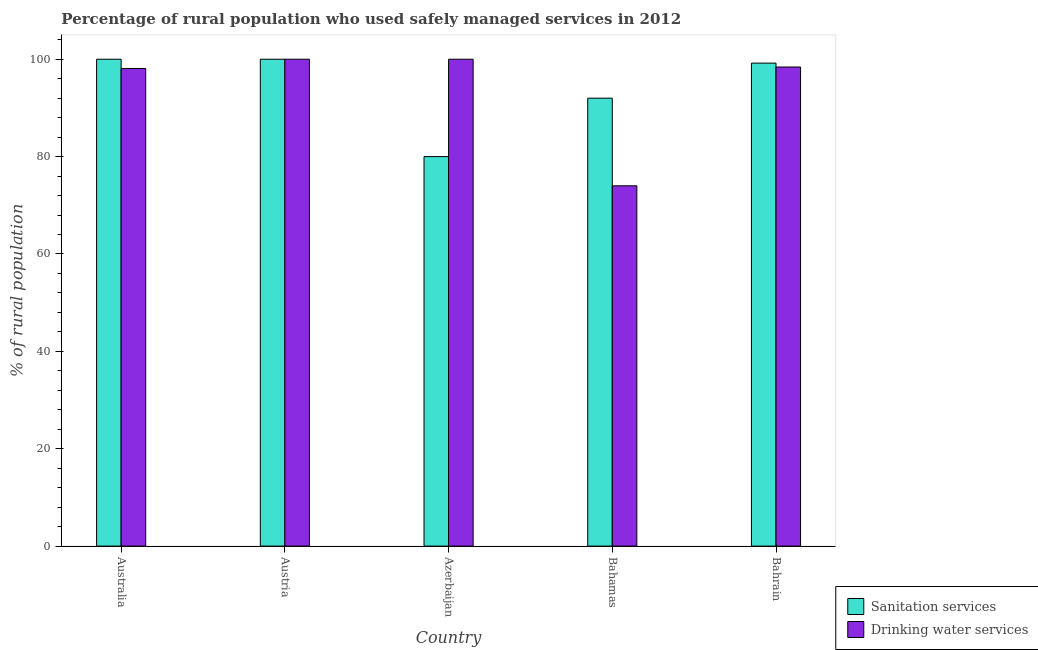How many groups of bars are there?
Make the answer very short. 5. How many bars are there on the 2nd tick from the right?
Offer a terse response. 2. What is the label of the 1st group of bars from the left?
Ensure brevity in your answer.  Australia. In how many cases, is the number of bars for a given country not equal to the number of legend labels?
Provide a succinct answer. 0. What is the percentage of rural population who used sanitation services in Austria?
Offer a terse response. 100. In which country was the percentage of rural population who used sanitation services minimum?
Make the answer very short. Azerbaijan. What is the total percentage of rural population who used sanitation services in the graph?
Your response must be concise. 471.2. What is the difference between the percentage of rural population who used drinking water services in Australia and that in Austria?
Your answer should be very brief. -1.9. What is the difference between the percentage of rural population who used drinking water services in Bahrain and the percentage of rural population who used sanitation services in Austria?
Offer a terse response. -1.6. What is the average percentage of rural population who used sanitation services per country?
Your answer should be very brief. 94.24. What is the difference between the percentage of rural population who used drinking water services and percentage of rural population who used sanitation services in Bahrain?
Give a very brief answer. -0.8. In how many countries, is the percentage of rural population who used sanitation services greater than the average percentage of rural population who used sanitation services taken over all countries?
Ensure brevity in your answer.  3. What does the 1st bar from the left in Bahamas represents?
Your answer should be compact. Sanitation services. What does the 1st bar from the right in Bahamas represents?
Ensure brevity in your answer.  Drinking water services. How many bars are there?
Offer a very short reply. 10. Are all the bars in the graph horizontal?
Your answer should be very brief. No. How many countries are there in the graph?
Give a very brief answer. 5. Are the values on the major ticks of Y-axis written in scientific E-notation?
Offer a very short reply. No. How many legend labels are there?
Your answer should be compact. 2. What is the title of the graph?
Your answer should be compact. Percentage of rural population who used safely managed services in 2012. Does "Researchers" appear as one of the legend labels in the graph?
Offer a terse response. No. What is the label or title of the Y-axis?
Offer a terse response. % of rural population. What is the % of rural population in Drinking water services in Australia?
Provide a succinct answer. 98.1. What is the % of rural population of Drinking water services in Austria?
Your response must be concise. 100. What is the % of rural population in Sanitation services in Azerbaijan?
Make the answer very short. 80. What is the % of rural population of Drinking water services in Azerbaijan?
Offer a terse response. 100. What is the % of rural population in Sanitation services in Bahamas?
Your answer should be very brief. 92. What is the % of rural population in Drinking water services in Bahamas?
Ensure brevity in your answer.  74. What is the % of rural population in Sanitation services in Bahrain?
Provide a succinct answer. 99.2. What is the % of rural population in Drinking water services in Bahrain?
Your answer should be compact. 98.4. Across all countries, what is the maximum % of rural population of Sanitation services?
Offer a terse response. 100. Across all countries, what is the minimum % of rural population in Sanitation services?
Offer a terse response. 80. Across all countries, what is the minimum % of rural population of Drinking water services?
Offer a very short reply. 74. What is the total % of rural population of Sanitation services in the graph?
Provide a succinct answer. 471.2. What is the total % of rural population in Drinking water services in the graph?
Your response must be concise. 470.5. What is the difference between the % of rural population of Sanitation services in Australia and that in Austria?
Your answer should be compact. 0. What is the difference between the % of rural population of Drinking water services in Australia and that in Austria?
Give a very brief answer. -1.9. What is the difference between the % of rural population in Sanitation services in Australia and that in Azerbaijan?
Your response must be concise. 20. What is the difference between the % of rural population in Drinking water services in Australia and that in Azerbaijan?
Provide a succinct answer. -1.9. What is the difference between the % of rural population in Sanitation services in Australia and that in Bahamas?
Offer a terse response. 8. What is the difference between the % of rural population of Drinking water services in Australia and that in Bahamas?
Your answer should be compact. 24.1. What is the difference between the % of rural population of Sanitation services in Australia and that in Bahrain?
Keep it short and to the point. 0.8. What is the difference between the % of rural population in Drinking water services in Australia and that in Bahrain?
Your response must be concise. -0.3. What is the difference between the % of rural population in Sanitation services in Austria and that in Azerbaijan?
Your answer should be compact. 20. What is the difference between the % of rural population in Drinking water services in Austria and that in Bahamas?
Give a very brief answer. 26. What is the difference between the % of rural population of Sanitation services in Azerbaijan and that in Bahrain?
Your answer should be very brief. -19.2. What is the difference between the % of rural population of Drinking water services in Bahamas and that in Bahrain?
Provide a short and direct response. -24.4. What is the difference between the % of rural population in Sanitation services in Australia and the % of rural population in Drinking water services in Azerbaijan?
Your answer should be compact. 0. What is the difference between the % of rural population in Sanitation services in Australia and the % of rural population in Drinking water services in Bahrain?
Give a very brief answer. 1.6. What is the difference between the % of rural population of Sanitation services in Austria and the % of rural population of Drinking water services in Bahamas?
Ensure brevity in your answer.  26. What is the difference between the % of rural population of Sanitation services in Austria and the % of rural population of Drinking water services in Bahrain?
Make the answer very short. 1.6. What is the difference between the % of rural population of Sanitation services in Azerbaijan and the % of rural population of Drinking water services in Bahamas?
Provide a succinct answer. 6. What is the difference between the % of rural population in Sanitation services in Azerbaijan and the % of rural population in Drinking water services in Bahrain?
Provide a succinct answer. -18.4. What is the difference between the % of rural population of Sanitation services in Bahamas and the % of rural population of Drinking water services in Bahrain?
Provide a short and direct response. -6.4. What is the average % of rural population in Sanitation services per country?
Ensure brevity in your answer.  94.24. What is the average % of rural population of Drinking water services per country?
Your response must be concise. 94.1. What is the difference between the % of rural population of Sanitation services and % of rural population of Drinking water services in Australia?
Your answer should be compact. 1.9. What is the difference between the % of rural population in Sanitation services and % of rural population in Drinking water services in Azerbaijan?
Provide a short and direct response. -20. What is the difference between the % of rural population in Sanitation services and % of rural population in Drinking water services in Bahrain?
Keep it short and to the point. 0.8. What is the ratio of the % of rural population in Drinking water services in Australia to that in Austria?
Provide a short and direct response. 0.98. What is the ratio of the % of rural population of Sanitation services in Australia to that in Azerbaijan?
Your answer should be very brief. 1.25. What is the ratio of the % of rural population of Drinking water services in Australia to that in Azerbaijan?
Offer a terse response. 0.98. What is the ratio of the % of rural population of Sanitation services in Australia to that in Bahamas?
Offer a very short reply. 1.09. What is the ratio of the % of rural population of Drinking water services in Australia to that in Bahamas?
Offer a very short reply. 1.33. What is the ratio of the % of rural population in Sanitation services in Australia to that in Bahrain?
Offer a very short reply. 1.01. What is the ratio of the % of rural population of Drinking water services in Australia to that in Bahrain?
Your answer should be compact. 1. What is the ratio of the % of rural population in Drinking water services in Austria to that in Azerbaijan?
Make the answer very short. 1. What is the ratio of the % of rural population of Sanitation services in Austria to that in Bahamas?
Keep it short and to the point. 1.09. What is the ratio of the % of rural population in Drinking water services in Austria to that in Bahamas?
Give a very brief answer. 1.35. What is the ratio of the % of rural population in Sanitation services in Austria to that in Bahrain?
Offer a very short reply. 1.01. What is the ratio of the % of rural population in Drinking water services in Austria to that in Bahrain?
Keep it short and to the point. 1.02. What is the ratio of the % of rural population in Sanitation services in Azerbaijan to that in Bahamas?
Your answer should be compact. 0.87. What is the ratio of the % of rural population in Drinking water services in Azerbaijan to that in Bahamas?
Your answer should be compact. 1.35. What is the ratio of the % of rural population in Sanitation services in Azerbaijan to that in Bahrain?
Make the answer very short. 0.81. What is the ratio of the % of rural population of Drinking water services in Azerbaijan to that in Bahrain?
Your answer should be very brief. 1.02. What is the ratio of the % of rural population of Sanitation services in Bahamas to that in Bahrain?
Give a very brief answer. 0.93. What is the ratio of the % of rural population in Drinking water services in Bahamas to that in Bahrain?
Offer a very short reply. 0.75. What is the difference between the highest and the lowest % of rural population of Sanitation services?
Your answer should be compact. 20. What is the difference between the highest and the lowest % of rural population of Drinking water services?
Provide a short and direct response. 26. 